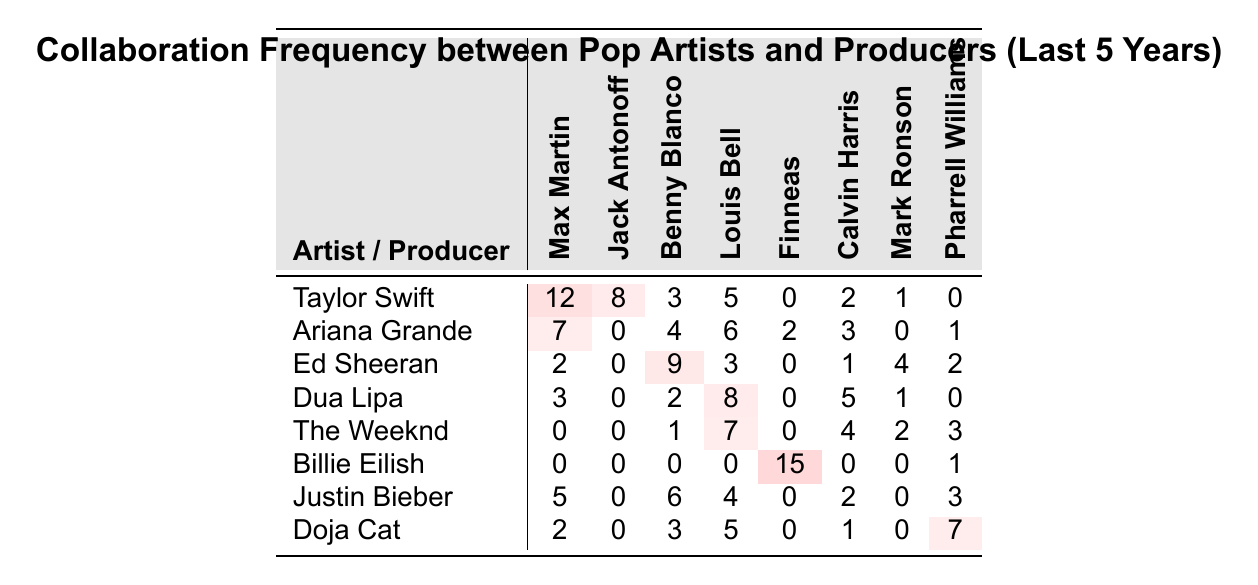What is the highest number of collaborations an artist has had with a producer? Looking at the table, we can see that Billie Eilish has the highest number of collaborations with Finneas, which is 15.
Answer: 15 Which artist collaborated with Max Martin the most? Checking the row for each artist under the Max Martin column, Taylor Swift has the highest number of collaborations with 12.
Answer: Taylor Swift Which producer has collaborated with the least number of artists? All producers have been compared in their total collaboration counts across artists. Max Martin has 12 + 7 + 2 + 3 + 0 + 0 + 5 + 2 = 29 collaborations, Jack Antonoff has 8 + 0 + 0 + 0 + 0 + 0 + 0 + 0 = 8 collaborations, Benny Blanco has 3 + 4 + 9 + 2 + 1 + 0 + 6 + 3 = 28 collaborations, and so forth. Jack Antonoff has the least with 8.
Answer: Jack Antonoff What is the total number of collaborations for Dua Lipa? To find this out, we sum the number of collaborations across all producers listed in the row for Dua Lipa: 3 + 0 + 2 + 8 + 0 + 5 + 1 + 0 = 19.
Answer: 19 Which artist has the most collaborations overall and what is that number? To find the overall collaborations for each artist, we sum the values in each row: Taylor Swift (12+8+3+5+0+2+1+0=31), Ariana Grande (7+0+4+6+2+3+0+1=23), Ed Sheeran (2+0+9+3+0+1+4+2=21), Dua Lipa (19), The Weeknd (13), Billie Eilish (16), Justin Bieber (24), and Doja Cat (18). Taylor Swift has the highest with 31 collaborations.
Answer: Taylor Swift, 31 How many more collaborations does Justin Bieber have compared to The Weeknd? First, calculate Justin Bieber's collaborations (5 + 0 + 6 + 4 + 0 + 2 + 0 + 3 = 20) and The Weeknd's (0 + 0 + 1 + 7 + 0 + 4 + 2 + 3 = 17). The difference is 20 - 17 = 3.
Answer: 3 Is it true that Ariana Grande collaborated with Pharrell Williams? Checking the table in Ariana Grande's row under Pharrell Williams, there is a 1. This means yes, she did collaborate with him.
Answer: Yes Which artist collaborated with the highest number of different producers? We can count the non-zero collaboration entries for each artist: Taylor Swift (7), Ariana Grande (6), Ed Sheeran (5), Dua Lipa (5), The Weeknd (4), Billie Eilish (3), Justin Bieber (5), Doja Cat (5). Taylor Swift has the most unique collaborations at 7.
Answer: Taylor Swift Which producer had no collaborations with Ariana Grande? Looking at Ariana Grande’s row, we can see the collaborations with each producer. She has zero collaborations with Jack Antonoff.
Answer: Jack Antonoff What is the average number of collaborations for Doja Cat? To calculate the average, we sum Doja Cat's collaborations (2 + 0 + 3 + 5 + 0 + 1 + 0 + 7 = 18), then divide by the number of producers (8). Thus, the average is 18 / 8 = 2.25.
Answer: 2.25 